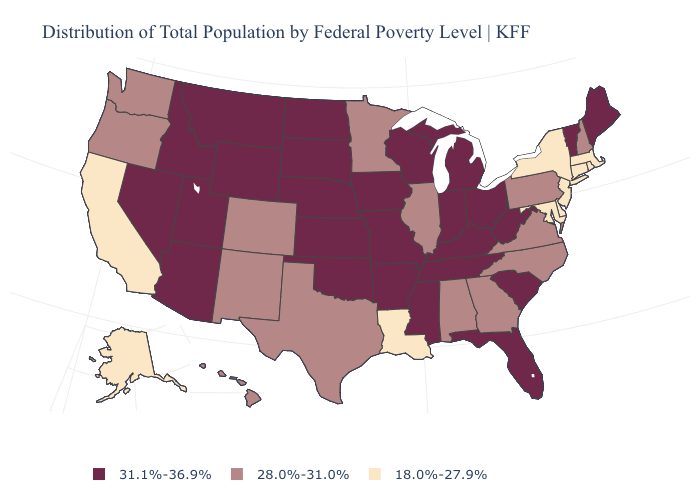Does the map have missing data?
Give a very brief answer. No. What is the value of Indiana?
Give a very brief answer. 31.1%-36.9%. What is the highest value in states that border Arkansas?
Quick response, please. 31.1%-36.9%. Name the states that have a value in the range 31.1%-36.9%?
Keep it brief. Arizona, Arkansas, Florida, Idaho, Indiana, Iowa, Kansas, Kentucky, Maine, Michigan, Mississippi, Missouri, Montana, Nebraska, Nevada, North Dakota, Ohio, Oklahoma, South Carolina, South Dakota, Tennessee, Utah, Vermont, West Virginia, Wisconsin, Wyoming. Name the states that have a value in the range 31.1%-36.9%?
Keep it brief. Arizona, Arkansas, Florida, Idaho, Indiana, Iowa, Kansas, Kentucky, Maine, Michigan, Mississippi, Missouri, Montana, Nebraska, Nevada, North Dakota, Ohio, Oklahoma, South Carolina, South Dakota, Tennessee, Utah, Vermont, West Virginia, Wisconsin, Wyoming. What is the value of Delaware?
Give a very brief answer. 18.0%-27.9%. Name the states that have a value in the range 28.0%-31.0%?
Keep it brief. Alabama, Colorado, Georgia, Hawaii, Illinois, Minnesota, New Hampshire, New Mexico, North Carolina, Oregon, Pennsylvania, Texas, Virginia, Washington. Name the states that have a value in the range 28.0%-31.0%?
Give a very brief answer. Alabama, Colorado, Georgia, Hawaii, Illinois, Minnesota, New Hampshire, New Mexico, North Carolina, Oregon, Pennsylvania, Texas, Virginia, Washington. Among the states that border Arizona , does Nevada have the lowest value?
Short answer required. No. What is the value of Minnesota?
Short answer required. 28.0%-31.0%. Does the first symbol in the legend represent the smallest category?
Answer briefly. No. Does the map have missing data?
Write a very short answer. No. Does Minnesota have the highest value in the MidWest?
Short answer required. No. 